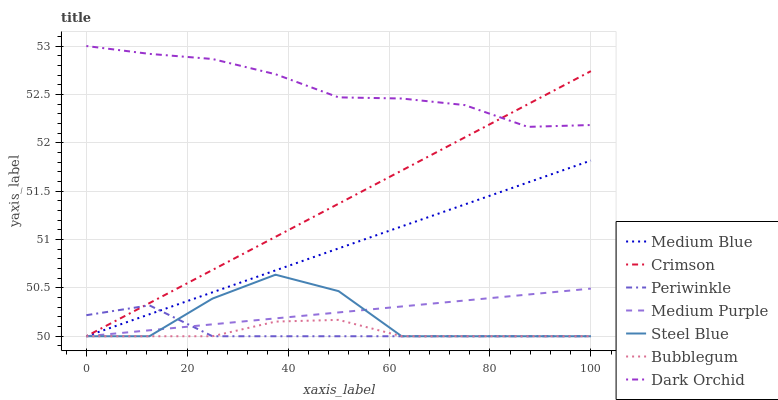Does Steel Blue have the minimum area under the curve?
Answer yes or no. No. Does Steel Blue have the maximum area under the curve?
Answer yes or no. No. Is Bubblegum the smoothest?
Answer yes or no. No. Is Bubblegum the roughest?
Answer yes or no. No. Does Dark Orchid have the lowest value?
Answer yes or no. No. Does Steel Blue have the highest value?
Answer yes or no. No. Is Medium Purple less than Dark Orchid?
Answer yes or no. Yes. Is Dark Orchid greater than Steel Blue?
Answer yes or no. Yes. Does Medium Purple intersect Dark Orchid?
Answer yes or no. No. 